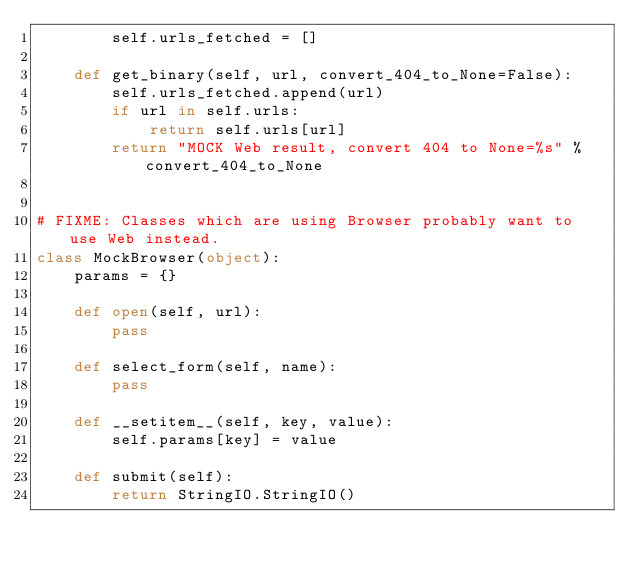Convert code to text. <code><loc_0><loc_0><loc_500><loc_500><_Python_>        self.urls_fetched = []

    def get_binary(self, url, convert_404_to_None=False):
        self.urls_fetched.append(url)
        if url in self.urls:
            return self.urls[url]
        return "MOCK Web result, convert 404 to None=%s" % convert_404_to_None


# FIXME: Classes which are using Browser probably want to use Web instead.
class MockBrowser(object):
    params = {}

    def open(self, url):
        pass

    def select_form(self, name):
        pass

    def __setitem__(self, key, value):
        self.params[key] = value

    def submit(self):
        return StringIO.StringIO()
</code> 